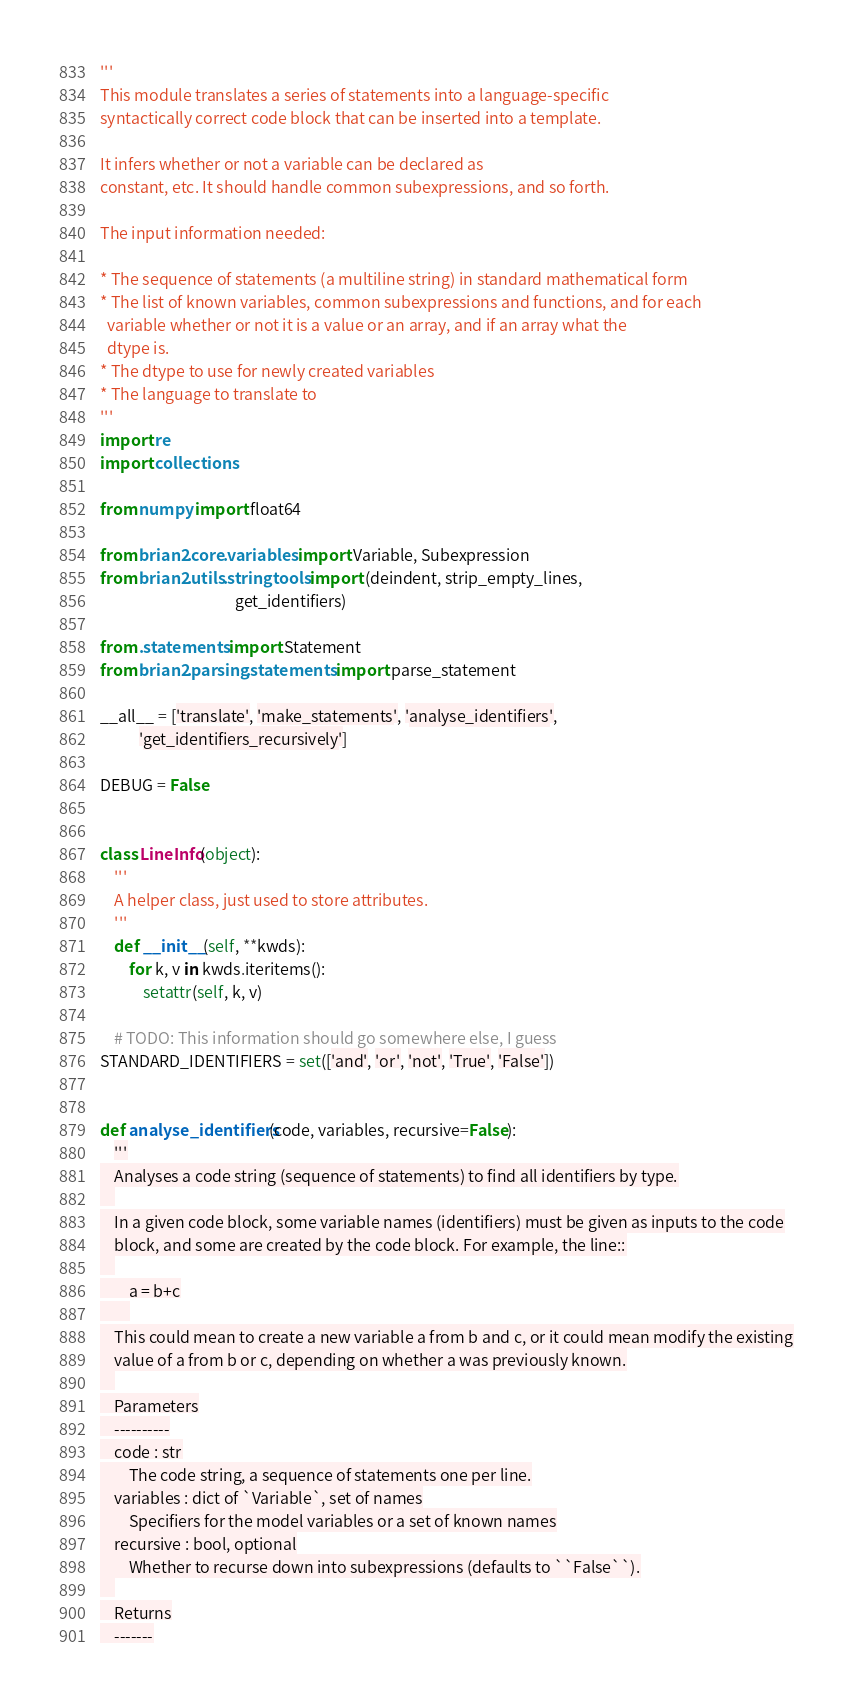Convert code to text. <code><loc_0><loc_0><loc_500><loc_500><_Python_>'''
This module translates a series of statements into a language-specific
syntactically correct code block that can be inserted into a template.

It infers whether or not a variable can be declared as
constant, etc. It should handle common subexpressions, and so forth.

The input information needed:

* The sequence of statements (a multiline string) in standard mathematical form
* The list of known variables, common subexpressions and functions, and for each
  variable whether or not it is a value or an array, and if an array what the
  dtype is.
* The dtype to use for newly created variables
* The language to translate to
'''
import re
import collections

from numpy import float64

from brian2.core.variables import Variable, Subexpression
from brian2.utils.stringtools import (deindent, strip_empty_lines,
                                      get_identifiers)

from .statements import Statement
from brian2.parsing.statements import parse_statement

__all__ = ['translate', 'make_statements', 'analyse_identifiers',
           'get_identifiers_recursively']

DEBUG = False


class LineInfo(object):
    '''
    A helper class, just used to store attributes.
    '''
    def __init__(self, **kwds):
        for k, v in kwds.iteritems():
            setattr(self, k, v)

    # TODO: This information should go somewhere else, I guess
STANDARD_IDENTIFIERS = set(['and', 'or', 'not', 'True', 'False'])


def analyse_identifiers(code, variables, recursive=False):
    '''
    Analyses a code string (sequence of statements) to find all identifiers by type.
    
    In a given code block, some variable names (identifiers) must be given as inputs to the code
    block, and some are created by the code block. For example, the line::
    
        a = b+c
        
    This could mean to create a new variable a from b and c, or it could mean modify the existing
    value of a from b or c, depending on whether a was previously known.
    
    Parameters
    ----------
    code : str
        The code string, a sequence of statements one per line.
    variables : dict of `Variable`, set of names
        Specifiers for the model variables or a set of known names
    recursive : bool, optional
        Whether to recurse down into subexpressions (defaults to ``False``).
    
    Returns
    -------</code> 